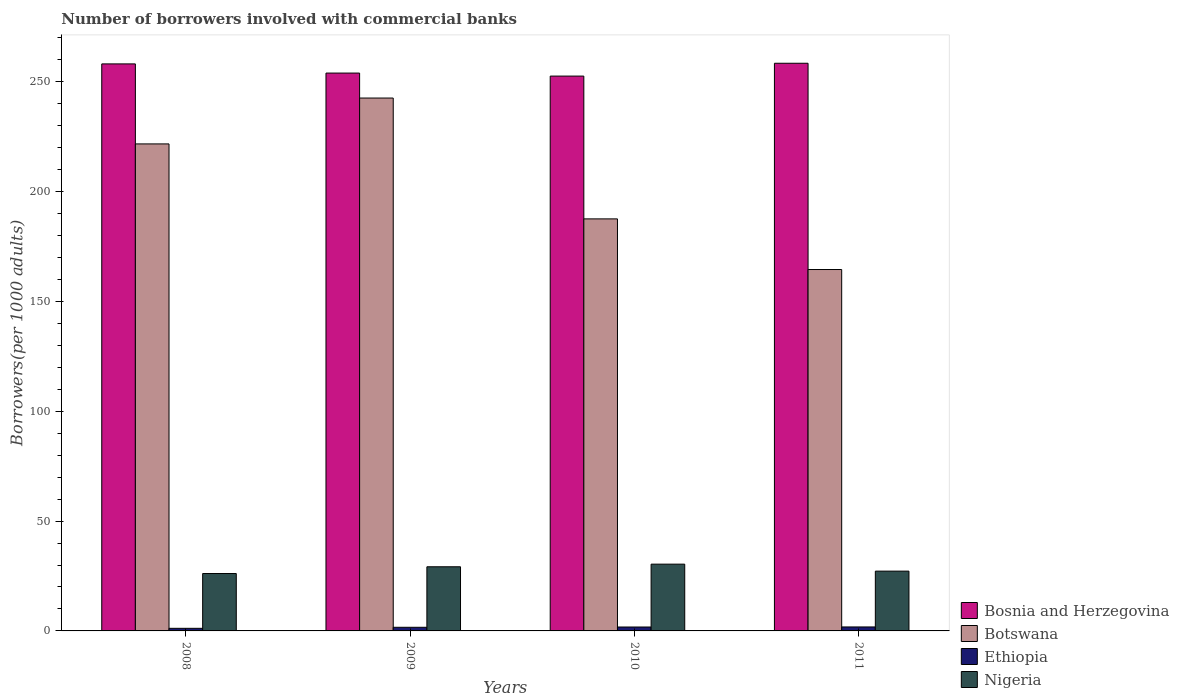How many different coloured bars are there?
Keep it short and to the point. 4. Are the number of bars per tick equal to the number of legend labels?
Your answer should be compact. Yes. How many bars are there on the 3rd tick from the left?
Offer a very short reply. 4. How many bars are there on the 4th tick from the right?
Keep it short and to the point. 4. What is the number of borrowers involved with commercial banks in Nigeria in 2008?
Provide a short and direct response. 26.12. Across all years, what is the maximum number of borrowers involved with commercial banks in Ethiopia?
Offer a terse response. 1.81. Across all years, what is the minimum number of borrowers involved with commercial banks in Bosnia and Herzegovina?
Your response must be concise. 252.52. In which year was the number of borrowers involved with commercial banks in Nigeria minimum?
Keep it short and to the point. 2008. What is the total number of borrowers involved with commercial banks in Botswana in the graph?
Provide a short and direct response. 816.18. What is the difference between the number of borrowers involved with commercial banks in Nigeria in 2008 and that in 2009?
Offer a terse response. -3.08. What is the difference between the number of borrowers involved with commercial banks in Ethiopia in 2008 and the number of borrowers involved with commercial banks in Nigeria in 2011?
Provide a short and direct response. -26.03. What is the average number of borrowers involved with commercial banks in Bosnia and Herzegovina per year?
Provide a succinct answer. 255.71. In the year 2011, what is the difference between the number of borrowers involved with commercial banks in Nigeria and number of borrowers involved with commercial banks in Botswana?
Keep it short and to the point. -137.26. What is the ratio of the number of borrowers involved with commercial banks in Ethiopia in 2009 to that in 2011?
Ensure brevity in your answer.  0.91. Is the number of borrowers involved with commercial banks in Botswana in 2010 less than that in 2011?
Your response must be concise. No. What is the difference between the highest and the second highest number of borrowers involved with commercial banks in Bosnia and Herzegovina?
Offer a very short reply. 0.29. What is the difference between the highest and the lowest number of borrowers involved with commercial banks in Ethiopia?
Provide a succinct answer. 0.63. In how many years, is the number of borrowers involved with commercial banks in Botswana greater than the average number of borrowers involved with commercial banks in Botswana taken over all years?
Offer a terse response. 2. What does the 1st bar from the left in 2008 represents?
Provide a short and direct response. Bosnia and Herzegovina. What does the 2nd bar from the right in 2008 represents?
Provide a short and direct response. Ethiopia. How many bars are there?
Keep it short and to the point. 16. How many years are there in the graph?
Provide a succinct answer. 4. What is the difference between two consecutive major ticks on the Y-axis?
Give a very brief answer. 50. Where does the legend appear in the graph?
Your answer should be very brief. Bottom right. How many legend labels are there?
Provide a short and direct response. 4. How are the legend labels stacked?
Your response must be concise. Vertical. What is the title of the graph?
Give a very brief answer. Number of borrowers involved with commercial banks. What is the label or title of the X-axis?
Provide a succinct answer. Years. What is the label or title of the Y-axis?
Ensure brevity in your answer.  Borrowers(per 1000 adults). What is the Borrowers(per 1000 adults) of Bosnia and Herzegovina in 2008?
Provide a short and direct response. 258.06. What is the Borrowers(per 1000 adults) of Botswana in 2008?
Keep it short and to the point. 221.65. What is the Borrowers(per 1000 adults) of Ethiopia in 2008?
Keep it short and to the point. 1.18. What is the Borrowers(per 1000 adults) of Nigeria in 2008?
Your answer should be compact. 26.12. What is the Borrowers(per 1000 adults) of Bosnia and Herzegovina in 2009?
Make the answer very short. 253.89. What is the Borrowers(per 1000 adults) of Botswana in 2009?
Ensure brevity in your answer.  242.52. What is the Borrowers(per 1000 adults) in Ethiopia in 2009?
Give a very brief answer. 1.65. What is the Borrowers(per 1000 adults) of Nigeria in 2009?
Provide a succinct answer. 29.2. What is the Borrowers(per 1000 adults) of Bosnia and Herzegovina in 2010?
Your response must be concise. 252.52. What is the Borrowers(per 1000 adults) in Botswana in 2010?
Provide a short and direct response. 187.53. What is the Borrowers(per 1000 adults) of Ethiopia in 2010?
Give a very brief answer. 1.78. What is the Borrowers(per 1000 adults) of Nigeria in 2010?
Your answer should be compact. 30.39. What is the Borrowers(per 1000 adults) in Bosnia and Herzegovina in 2011?
Provide a short and direct response. 258.35. What is the Borrowers(per 1000 adults) of Botswana in 2011?
Make the answer very short. 164.48. What is the Borrowers(per 1000 adults) of Ethiopia in 2011?
Provide a succinct answer. 1.81. What is the Borrowers(per 1000 adults) of Nigeria in 2011?
Offer a very short reply. 27.21. Across all years, what is the maximum Borrowers(per 1000 adults) of Bosnia and Herzegovina?
Provide a succinct answer. 258.35. Across all years, what is the maximum Borrowers(per 1000 adults) of Botswana?
Ensure brevity in your answer.  242.52. Across all years, what is the maximum Borrowers(per 1000 adults) in Ethiopia?
Offer a terse response. 1.81. Across all years, what is the maximum Borrowers(per 1000 adults) in Nigeria?
Your answer should be very brief. 30.39. Across all years, what is the minimum Borrowers(per 1000 adults) of Bosnia and Herzegovina?
Your response must be concise. 252.52. Across all years, what is the minimum Borrowers(per 1000 adults) of Botswana?
Offer a very short reply. 164.48. Across all years, what is the minimum Borrowers(per 1000 adults) of Ethiopia?
Offer a terse response. 1.18. Across all years, what is the minimum Borrowers(per 1000 adults) of Nigeria?
Offer a very short reply. 26.12. What is the total Borrowers(per 1000 adults) of Bosnia and Herzegovina in the graph?
Keep it short and to the point. 1022.83. What is the total Borrowers(per 1000 adults) in Botswana in the graph?
Ensure brevity in your answer.  816.18. What is the total Borrowers(per 1000 adults) of Ethiopia in the graph?
Keep it short and to the point. 6.43. What is the total Borrowers(per 1000 adults) in Nigeria in the graph?
Your answer should be very brief. 112.92. What is the difference between the Borrowers(per 1000 adults) in Bosnia and Herzegovina in 2008 and that in 2009?
Give a very brief answer. 4.17. What is the difference between the Borrowers(per 1000 adults) in Botswana in 2008 and that in 2009?
Keep it short and to the point. -20.87. What is the difference between the Borrowers(per 1000 adults) of Ethiopia in 2008 and that in 2009?
Your answer should be compact. -0.47. What is the difference between the Borrowers(per 1000 adults) of Nigeria in 2008 and that in 2009?
Offer a terse response. -3.08. What is the difference between the Borrowers(per 1000 adults) in Bosnia and Herzegovina in 2008 and that in 2010?
Offer a very short reply. 5.55. What is the difference between the Borrowers(per 1000 adults) of Botswana in 2008 and that in 2010?
Keep it short and to the point. 34.12. What is the difference between the Borrowers(per 1000 adults) of Ethiopia in 2008 and that in 2010?
Offer a very short reply. -0.6. What is the difference between the Borrowers(per 1000 adults) of Nigeria in 2008 and that in 2010?
Provide a succinct answer. -4.27. What is the difference between the Borrowers(per 1000 adults) in Bosnia and Herzegovina in 2008 and that in 2011?
Make the answer very short. -0.29. What is the difference between the Borrowers(per 1000 adults) of Botswana in 2008 and that in 2011?
Keep it short and to the point. 57.17. What is the difference between the Borrowers(per 1000 adults) in Ethiopia in 2008 and that in 2011?
Offer a terse response. -0.63. What is the difference between the Borrowers(per 1000 adults) in Nigeria in 2008 and that in 2011?
Your answer should be compact. -1.09. What is the difference between the Borrowers(per 1000 adults) in Bosnia and Herzegovina in 2009 and that in 2010?
Your answer should be compact. 1.38. What is the difference between the Borrowers(per 1000 adults) of Botswana in 2009 and that in 2010?
Provide a short and direct response. 55. What is the difference between the Borrowers(per 1000 adults) in Ethiopia in 2009 and that in 2010?
Your answer should be compact. -0.13. What is the difference between the Borrowers(per 1000 adults) in Nigeria in 2009 and that in 2010?
Give a very brief answer. -1.19. What is the difference between the Borrowers(per 1000 adults) in Bosnia and Herzegovina in 2009 and that in 2011?
Keep it short and to the point. -4.46. What is the difference between the Borrowers(per 1000 adults) of Botswana in 2009 and that in 2011?
Provide a short and direct response. 78.04. What is the difference between the Borrowers(per 1000 adults) in Ethiopia in 2009 and that in 2011?
Ensure brevity in your answer.  -0.16. What is the difference between the Borrowers(per 1000 adults) of Nigeria in 2009 and that in 2011?
Your response must be concise. 1.98. What is the difference between the Borrowers(per 1000 adults) of Bosnia and Herzegovina in 2010 and that in 2011?
Your answer should be compact. -5.84. What is the difference between the Borrowers(per 1000 adults) of Botswana in 2010 and that in 2011?
Your answer should be very brief. 23.05. What is the difference between the Borrowers(per 1000 adults) of Ethiopia in 2010 and that in 2011?
Make the answer very short. -0.02. What is the difference between the Borrowers(per 1000 adults) of Nigeria in 2010 and that in 2011?
Make the answer very short. 3.17. What is the difference between the Borrowers(per 1000 adults) in Bosnia and Herzegovina in 2008 and the Borrowers(per 1000 adults) in Botswana in 2009?
Ensure brevity in your answer.  15.54. What is the difference between the Borrowers(per 1000 adults) of Bosnia and Herzegovina in 2008 and the Borrowers(per 1000 adults) of Ethiopia in 2009?
Offer a very short reply. 256.41. What is the difference between the Borrowers(per 1000 adults) of Bosnia and Herzegovina in 2008 and the Borrowers(per 1000 adults) of Nigeria in 2009?
Provide a succinct answer. 228.87. What is the difference between the Borrowers(per 1000 adults) in Botswana in 2008 and the Borrowers(per 1000 adults) in Ethiopia in 2009?
Provide a succinct answer. 220. What is the difference between the Borrowers(per 1000 adults) of Botswana in 2008 and the Borrowers(per 1000 adults) of Nigeria in 2009?
Keep it short and to the point. 192.45. What is the difference between the Borrowers(per 1000 adults) in Ethiopia in 2008 and the Borrowers(per 1000 adults) in Nigeria in 2009?
Provide a succinct answer. -28.01. What is the difference between the Borrowers(per 1000 adults) in Bosnia and Herzegovina in 2008 and the Borrowers(per 1000 adults) in Botswana in 2010?
Offer a very short reply. 70.54. What is the difference between the Borrowers(per 1000 adults) of Bosnia and Herzegovina in 2008 and the Borrowers(per 1000 adults) of Ethiopia in 2010?
Make the answer very short. 256.28. What is the difference between the Borrowers(per 1000 adults) in Bosnia and Herzegovina in 2008 and the Borrowers(per 1000 adults) in Nigeria in 2010?
Provide a short and direct response. 227.68. What is the difference between the Borrowers(per 1000 adults) in Botswana in 2008 and the Borrowers(per 1000 adults) in Ethiopia in 2010?
Your response must be concise. 219.87. What is the difference between the Borrowers(per 1000 adults) of Botswana in 2008 and the Borrowers(per 1000 adults) of Nigeria in 2010?
Offer a terse response. 191.26. What is the difference between the Borrowers(per 1000 adults) of Ethiopia in 2008 and the Borrowers(per 1000 adults) of Nigeria in 2010?
Provide a succinct answer. -29.21. What is the difference between the Borrowers(per 1000 adults) of Bosnia and Herzegovina in 2008 and the Borrowers(per 1000 adults) of Botswana in 2011?
Provide a succinct answer. 93.58. What is the difference between the Borrowers(per 1000 adults) of Bosnia and Herzegovina in 2008 and the Borrowers(per 1000 adults) of Ethiopia in 2011?
Offer a terse response. 256.25. What is the difference between the Borrowers(per 1000 adults) of Bosnia and Herzegovina in 2008 and the Borrowers(per 1000 adults) of Nigeria in 2011?
Make the answer very short. 230.85. What is the difference between the Borrowers(per 1000 adults) of Botswana in 2008 and the Borrowers(per 1000 adults) of Ethiopia in 2011?
Your answer should be very brief. 219.84. What is the difference between the Borrowers(per 1000 adults) of Botswana in 2008 and the Borrowers(per 1000 adults) of Nigeria in 2011?
Provide a succinct answer. 194.44. What is the difference between the Borrowers(per 1000 adults) of Ethiopia in 2008 and the Borrowers(per 1000 adults) of Nigeria in 2011?
Offer a very short reply. -26.03. What is the difference between the Borrowers(per 1000 adults) in Bosnia and Herzegovina in 2009 and the Borrowers(per 1000 adults) in Botswana in 2010?
Provide a succinct answer. 66.36. What is the difference between the Borrowers(per 1000 adults) in Bosnia and Herzegovina in 2009 and the Borrowers(per 1000 adults) in Ethiopia in 2010?
Your answer should be very brief. 252.11. What is the difference between the Borrowers(per 1000 adults) in Bosnia and Herzegovina in 2009 and the Borrowers(per 1000 adults) in Nigeria in 2010?
Make the answer very short. 223.5. What is the difference between the Borrowers(per 1000 adults) in Botswana in 2009 and the Borrowers(per 1000 adults) in Ethiopia in 2010?
Offer a terse response. 240.74. What is the difference between the Borrowers(per 1000 adults) in Botswana in 2009 and the Borrowers(per 1000 adults) in Nigeria in 2010?
Provide a short and direct response. 212.14. What is the difference between the Borrowers(per 1000 adults) in Ethiopia in 2009 and the Borrowers(per 1000 adults) in Nigeria in 2010?
Your response must be concise. -28.74. What is the difference between the Borrowers(per 1000 adults) in Bosnia and Herzegovina in 2009 and the Borrowers(per 1000 adults) in Botswana in 2011?
Offer a terse response. 89.41. What is the difference between the Borrowers(per 1000 adults) of Bosnia and Herzegovina in 2009 and the Borrowers(per 1000 adults) of Ethiopia in 2011?
Your answer should be compact. 252.08. What is the difference between the Borrowers(per 1000 adults) of Bosnia and Herzegovina in 2009 and the Borrowers(per 1000 adults) of Nigeria in 2011?
Make the answer very short. 226.68. What is the difference between the Borrowers(per 1000 adults) in Botswana in 2009 and the Borrowers(per 1000 adults) in Ethiopia in 2011?
Keep it short and to the point. 240.71. What is the difference between the Borrowers(per 1000 adults) of Botswana in 2009 and the Borrowers(per 1000 adults) of Nigeria in 2011?
Ensure brevity in your answer.  215.31. What is the difference between the Borrowers(per 1000 adults) in Ethiopia in 2009 and the Borrowers(per 1000 adults) in Nigeria in 2011?
Your response must be concise. -25.56. What is the difference between the Borrowers(per 1000 adults) of Bosnia and Herzegovina in 2010 and the Borrowers(per 1000 adults) of Botswana in 2011?
Make the answer very short. 88.04. What is the difference between the Borrowers(per 1000 adults) in Bosnia and Herzegovina in 2010 and the Borrowers(per 1000 adults) in Ethiopia in 2011?
Your response must be concise. 250.71. What is the difference between the Borrowers(per 1000 adults) of Bosnia and Herzegovina in 2010 and the Borrowers(per 1000 adults) of Nigeria in 2011?
Offer a terse response. 225.3. What is the difference between the Borrowers(per 1000 adults) in Botswana in 2010 and the Borrowers(per 1000 adults) in Ethiopia in 2011?
Your response must be concise. 185.72. What is the difference between the Borrowers(per 1000 adults) in Botswana in 2010 and the Borrowers(per 1000 adults) in Nigeria in 2011?
Offer a terse response. 160.31. What is the difference between the Borrowers(per 1000 adults) of Ethiopia in 2010 and the Borrowers(per 1000 adults) of Nigeria in 2011?
Provide a succinct answer. -25.43. What is the average Borrowers(per 1000 adults) of Bosnia and Herzegovina per year?
Make the answer very short. 255.71. What is the average Borrowers(per 1000 adults) in Botswana per year?
Ensure brevity in your answer.  204.04. What is the average Borrowers(per 1000 adults) in Ethiopia per year?
Make the answer very short. 1.61. What is the average Borrowers(per 1000 adults) of Nigeria per year?
Ensure brevity in your answer.  28.23. In the year 2008, what is the difference between the Borrowers(per 1000 adults) of Bosnia and Herzegovina and Borrowers(per 1000 adults) of Botswana?
Offer a very short reply. 36.41. In the year 2008, what is the difference between the Borrowers(per 1000 adults) of Bosnia and Herzegovina and Borrowers(per 1000 adults) of Ethiopia?
Your answer should be very brief. 256.88. In the year 2008, what is the difference between the Borrowers(per 1000 adults) in Bosnia and Herzegovina and Borrowers(per 1000 adults) in Nigeria?
Ensure brevity in your answer.  231.94. In the year 2008, what is the difference between the Borrowers(per 1000 adults) in Botswana and Borrowers(per 1000 adults) in Ethiopia?
Your answer should be very brief. 220.47. In the year 2008, what is the difference between the Borrowers(per 1000 adults) in Botswana and Borrowers(per 1000 adults) in Nigeria?
Ensure brevity in your answer.  195.53. In the year 2008, what is the difference between the Borrowers(per 1000 adults) in Ethiopia and Borrowers(per 1000 adults) in Nigeria?
Your answer should be compact. -24.94. In the year 2009, what is the difference between the Borrowers(per 1000 adults) of Bosnia and Herzegovina and Borrowers(per 1000 adults) of Botswana?
Give a very brief answer. 11.37. In the year 2009, what is the difference between the Borrowers(per 1000 adults) of Bosnia and Herzegovina and Borrowers(per 1000 adults) of Ethiopia?
Your response must be concise. 252.24. In the year 2009, what is the difference between the Borrowers(per 1000 adults) in Bosnia and Herzegovina and Borrowers(per 1000 adults) in Nigeria?
Offer a very short reply. 224.7. In the year 2009, what is the difference between the Borrowers(per 1000 adults) in Botswana and Borrowers(per 1000 adults) in Ethiopia?
Offer a terse response. 240.87. In the year 2009, what is the difference between the Borrowers(per 1000 adults) of Botswana and Borrowers(per 1000 adults) of Nigeria?
Provide a succinct answer. 213.33. In the year 2009, what is the difference between the Borrowers(per 1000 adults) of Ethiopia and Borrowers(per 1000 adults) of Nigeria?
Your answer should be compact. -27.55. In the year 2010, what is the difference between the Borrowers(per 1000 adults) of Bosnia and Herzegovina and Borrowers(per 1000 adults) of Botswana?
Provide a succinct answer. 64.99. In the year 2010, what is the difference between the Borrowers(per 1000 adults) of Bosnia and Herzegovina and Borrowers(per 1000 adults) of Ethiopia?
Offer a terse response. 250.73. In the year 2010, what is the difference between the Borrowers(per 1000 adults) in Bosnia and Herzegovina and Borrowers(per 1000 adults) in Nigeria?
Your answer should be very brief. 222.13. In the year 2010, what is the difference between the Borrowers(per 1000 adults) of Botswana and Borrowers(per 1000 adults) of Ethiopia?
Give a very brief answer. 185.74. In the year 2010, what is the difference between the Borrowers(per 1000 adults) in Botswana and Borrowers(per 1000 adults) in Nigeria?
Your response must be concise. 157.14. In the year 2010, what is the difference between the Borrowers(per 1000 adults) in Ethiopia and Borrowers(per 1000 adults) in Nigeria?
Your response must be concise. -28.6. In the year 2011, what is the difference between the Borrowers(per 1000 adults) of Bosnia and Herzegovina and Borrowers(per 1000 adults) of Botswana?
Ensure brevity in your answer.  93.88. In the year 2011, what is the difference between the Borrowers(per 1000 adults) of Bosnia and Herzegovina and Borrowers(per 1000 adults) of Ethiopia?
Offer a very short reply. 256.55. In the year 2011, what is the difference between the Borrowers(per 1000 adults) of Bosnia and Herzegovina and Borrowers(per 1000 adults) of Nigeria?
Your answer should be very brief. 231.14. In the year 2011, what is the difference between the Borrowers(per 1000 adults) in Botswana and Borrowers(per 1000 adults) in Ethiopia?
Make the answer very short. 162.67. In the year 2011, what is the difference between the Borrowers(per 1000 adults) of Botswana and Borrowers(per 1000 adults) of Nigeria?
Keep it short and to the point. 137.26. In the year 2011, what is the difference between the Borrowers(per 1000 adults) in Ethiopia and Borrowers(per 1000 adults) in Nigeria?
Provide a succinct answer. -25.41. What is the ratio of the Borrowers(per 1000 adults) in Bosnia and Herzegovina in 2008 to that in 2009?
Ensure brevity in your answer.  1.02. What is the ratio of the Borrowers(per 1000 adults) of Botswana in 2008 to that in 2009?
Provide a short and direct response. 0.91. What is the ratio of the Borrowers(per 1000 adults) in Ethiopia in 2008 to that in 2009?
Provide a succinct answer. 0.72. What is the ratio of the Borrowers(per 1000 adults) in Nigeria in 2008 to that in 2009?
Provide a short and direct response. 0.89. What is the ratio of the Borrowers(per 1000 adults) of Bosnia and Herzegovina in 2008 to that in 2010?
Keep it short and to the point. 1.02. What is the ratio of the Borrowers(per 1000 adults) of Botswana in 2008 to that in 2010?
Your answer should be very brief. 1.18. What is the ratio of the Borrowers(per 1000 adults) of Ethiopia in 2008 to that in 2010?
Offer a very short reply. 0.66. What is the ratio of the Borrowers(per 1000 adults) of Nigeria in 2008 to that in 2010?
Ensure brevity in your answer.  0.86. What is the ratio of the Borrowers(per 1000 adults) in Botswana in 2008 to that in 2011?
Make the answer very short. 1.35. What is the ratio of the Borrowers(per 1000 adults) in Ethiopia in 2008 to that in 2011?
Offer a very short reply. 0.65. What is the ratio of the Borrowers(per 1000 adults) of Nigeria in 2008 to that in 2011?
Offer a terse response. 0.96. What is the ratio of the Borrowers(per 1000 adults) in Bosnia and Herzegovina in 2009 to that in 2010?
Make the answer very short. 1.01. What is the ratio of the Borrowers(per 1000 adults) in Botswana in 2009 to that in 2010?
Your answer should be compact. 1.29. What is the ratio of the Borrowers(per 1000 adults) in Ethiopia in 2009 to that in 2010?
Keep it short and to the point. 0.93. What is the ratio of the Borrowers(per 1000 adults) of Nigeria in 2009 to that in 2010?
Ensure brevity in your answer.  0.96. What is the ratio of the Borrowers(per 1000 adults) of Bosnia and Herzegovina in 2009 to that in 2011?
Provide a succinct answer. 0.98. What is the ratio of the Borrowers(per 1000 adults) of Botswana in 2009 to that in 2011?
Make the answer very short. 1.47. What is the ratio of the Borrowers(per 1000 adults) of Nigeria in 2009 to that in 2011?
Make the answer very short. 1.07. What is the ratio of the Borrowers(per 1000 adults) of Bosnia and Herzegovina in 2010 to that in 2011?
Make the answer very short. 0.98. What is the ratio of the Borrowers(per 1000 adults) of Botswana in 2010 to that in 2011?
Your answer should be compact. 1.14. What is the ratio of the Borrowers(per 1000 adults) in Ethiopia in 2010 to that in 2011?
Offer a terse response. 0.99. What is the ratio of the Borrowers(per 1000 adults) in Nigeria in 2010 to that in 2011?
Make the answer very short. 1.12. What is the difference between the highest and the second highest Borrowers(per 1000 adults) of Bosnia and Herzegovina?
Ensure brevity in your answer.  0.29. What is the difference between the highest and the second highest Borrowers(per 1000 adults) of Botswana?
Give a very brief answer. 20.87. What is the difference between the highest and the second highest Borrowers(per 1000 adults) of Ethiopia?
Your answer should be compact. 0.02. What is the difference between the highest and the second highest Borrowers(per 1000 adults) in Nigeria?
Ensure brevity in your answer.  1.19. What is the difference between the highest and the lowest Borrowers(per 1000 adults) of Bosnia and Herzegovina?
Offer a terse response. 5.84. What is the difference between the highest and the lowest Borrowers(per 1000 adults) of Botswana?
Your response must be concise. 78.04. What is the difference between the highest and the lowest Borrowers(per 1000 adults) in Ethiopia?
Make the answer very short. 0.63. What is the difference between the highest and the lowest Borrowers(per 1000 adults) of Nigeria?
Make the answer very short. 4.27. 